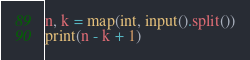Convert code to text. <code><loc_0><loc_0><loc_500><loc_500><_Python_>n, k = map(int, input().split())
print(n - k + 1)</code> 